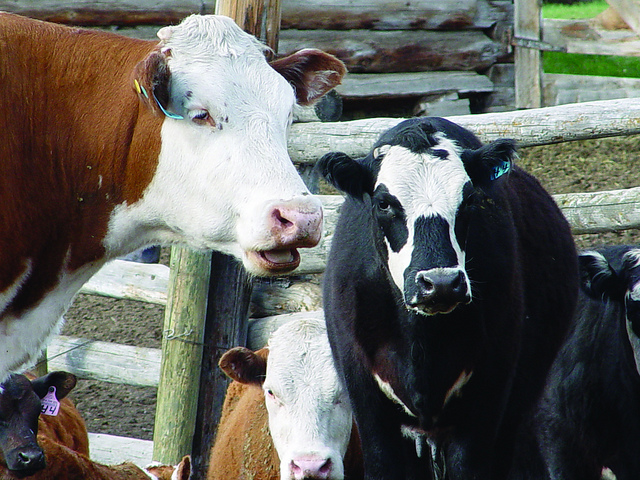What is the purpose of ear tagging in cows? Ear tagging in cows serves multiple purposes. It helps farmers identify individual animals for health records, breeding programs, and for tracking purposes in case of disease outbreak. Tags often contain unique numbers or electronic chips that store data about the animal. 